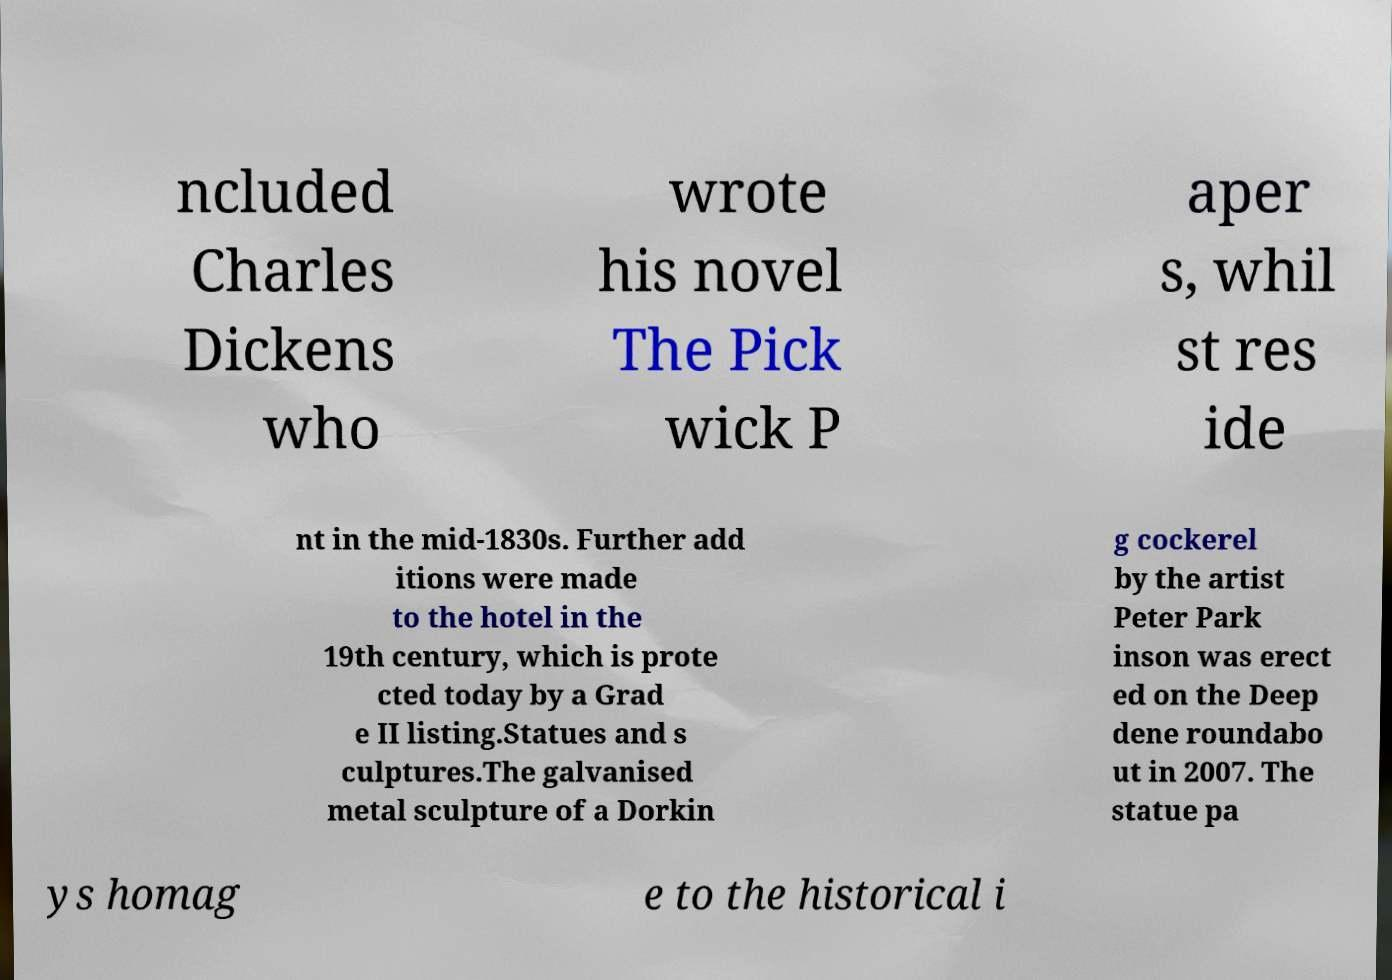Please read and relay the text visible in this image. What does it say? ncluded Charles Dickens who wrote his novel The Pick wick P aper s, whil st res ide nt in the mid-1830s. Further add itions were made to the hotel in the 19th century, which is prote cted today by a Grad e II listing.Statues and s culptures.The galvanised metal sculpture of a Dorkin g cockerel by the artist Peter Park inson was erect ed on the Deep dene roundabo ut in 2007. The statue pa ys homag e to the historical i 